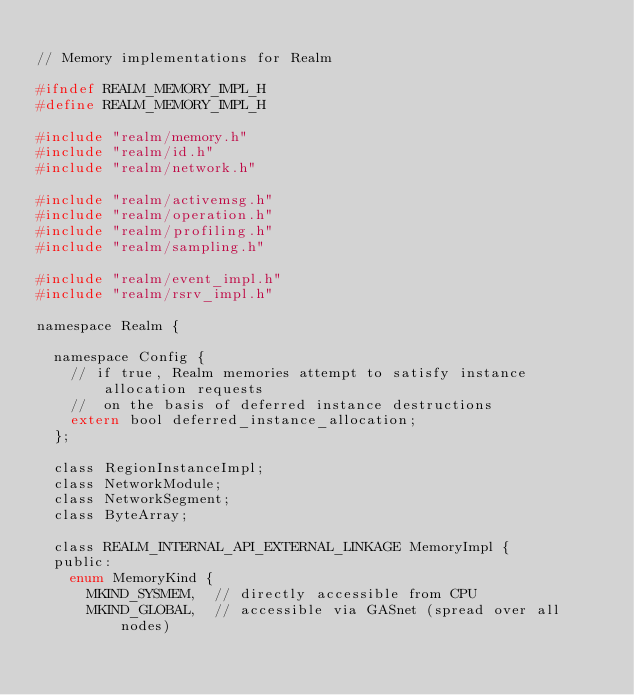Convert code to text. <code><loc_0><loc_0><loc_500><loc_500><_C_>
// Memory implementations for Realm

#ifndef REALM_MEMORY_IMPL_H
#define REALM_MEMORY_IMPL_H

#include "realm/memory.h"
#include "realm/id.h"
#include "realm/network.h"

#include "realm/activemsg.h"
#include "realm/operation.h"
#include "realm/profiling.h"
#include "realm/sampling.h"

#include "realm/event_impl.h"
#include "realm/rsrv_impl.h"

namespace Realm {

  namespace Config {
    // if true, Realm memories attempt to satisfy instance allocation requests
    //  on the basis of deferred instance destructions
    extern bool deferred_instance_allocation;
  };

  class RegionInstanceImpl;
  class NetworkModule;
  class NetworkSegment;
  class ByteArray;

  class REALM_INTERNAL_API_EXTERNAL_LINKAGE MemoryImpl {
  public:
    enum MemoryKind {
      MKIND_SYSMEM,  // directly accessible from CPU
      MKIND_GLOBAL,  // accessible via GASnet (spread over all nodes)</code> 